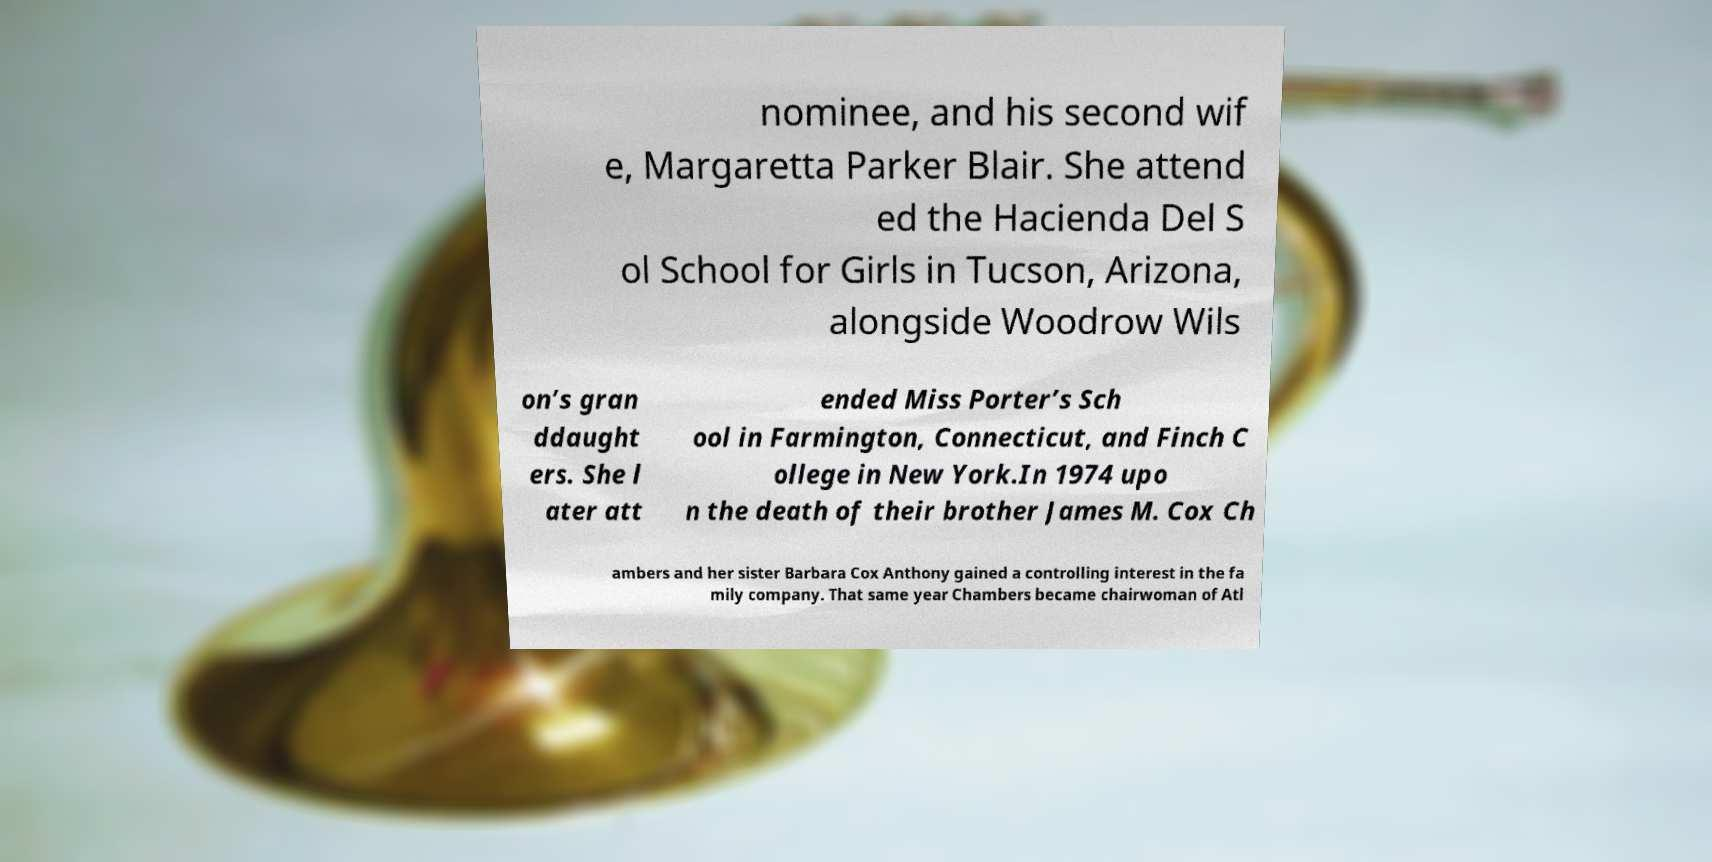For documentation purposes, I need the text within this image transcribed. Could you provide that? nominee, and his second wif e, Margaretta Parker Blair. She attend ed the Hacienda Del S ol School for Girls in Tucson, Arizona, alongside Woodrow Wils on’s gran ddaught ers. She l ater att ended Miss Porter’s Sch ool in Farmington, Connecticut, and Finch C ollege in New York.In 1974 upo n the death of their brother James M. Cox Ch ambers and her sister Barbara Cox Anthony gained a controlling interest in the fa mily company. That same year Chambers became chairwoman of Atl 